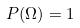<formula> <loc_0><loc_0><loc_500><loc_500>P ( \Omega ) = 1</formula> 